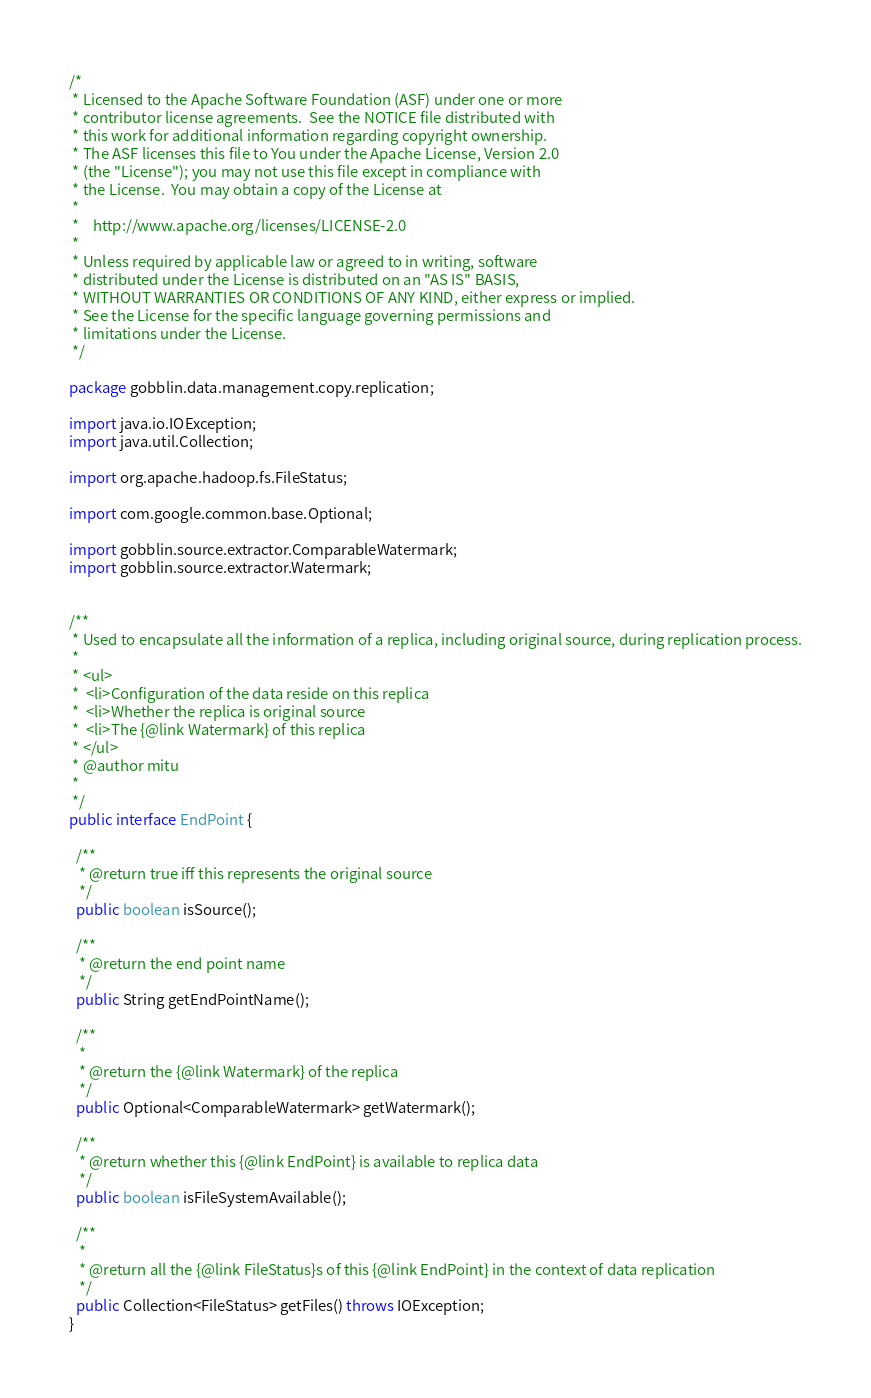<code> <loc_0><loc_0><loc_500><loc_500><_Java_>/*
 * Licensed to the Apache Software Foundation (ASF) under one or more
 * contributor license agreements.  See the NOTICE file distributed with
 * this work for additional information regarding copyright ownership.
 * The ASF licenses this file to You under the Apache License, Version 2.0
 * (the "License"); you may not use this file except in compliance with
 * the License.  You may obtain a copy of the License at
 *
 *    http://www.apache.org/licenses/LICENSE-2.0
 *
 * Unless required by applicable law or agreed to in writing, software
 * distributed under the License is distributed on an "AS IS" BASIS,
 * WITHOUT WARRANTIES OR CONDITIONS OF ANY KIND, either express or implied.
 * See the License for the specific language governing permissions and
 * limitations under the License.
 */

package gobblin.data.management.copy.replication;

import java.io.IOException;
import java.util.Collection;

import org.apache.hadoop.fs.FileStatus;

import com.google.common.base.Optional;

import gobblin.source.extractor.ComparableWatermark;
import gobblin.source.extractor.Watermark;


/**
 * Used to encapsulate all the information of a replica, including original source, during replication process.
 *
 * <ul>
 *  <li>Configuration of the data reside on this replica
 *  <li>Whether the replica is original source
 *  <li>The {@link Watermark} of this replica
 * </ul>
 * @author mitu
 *
 */
public interface EndPoint {

  /**
   * @return true iff this represents the original source
   */
  public boolean isSource();

  /**
   * @return the end point name
   */
  public String getEndPointName();

  /**
   *
   * @return the {@link Watermark} of the replica
   */
  public Optional<ComparableWatermark> getWatermark();

  /**
   * @return whether this {@link EndPoint} is available to replica data
   */
  public boolean isFileSystemAvailable();

  /**
   *
   * @return all the {@link FileStatus}s of this {@link EndPoint} in the context of data replication
   */
  public Collection<FileStatus> getFiles() throws IOException;
}
</code> 